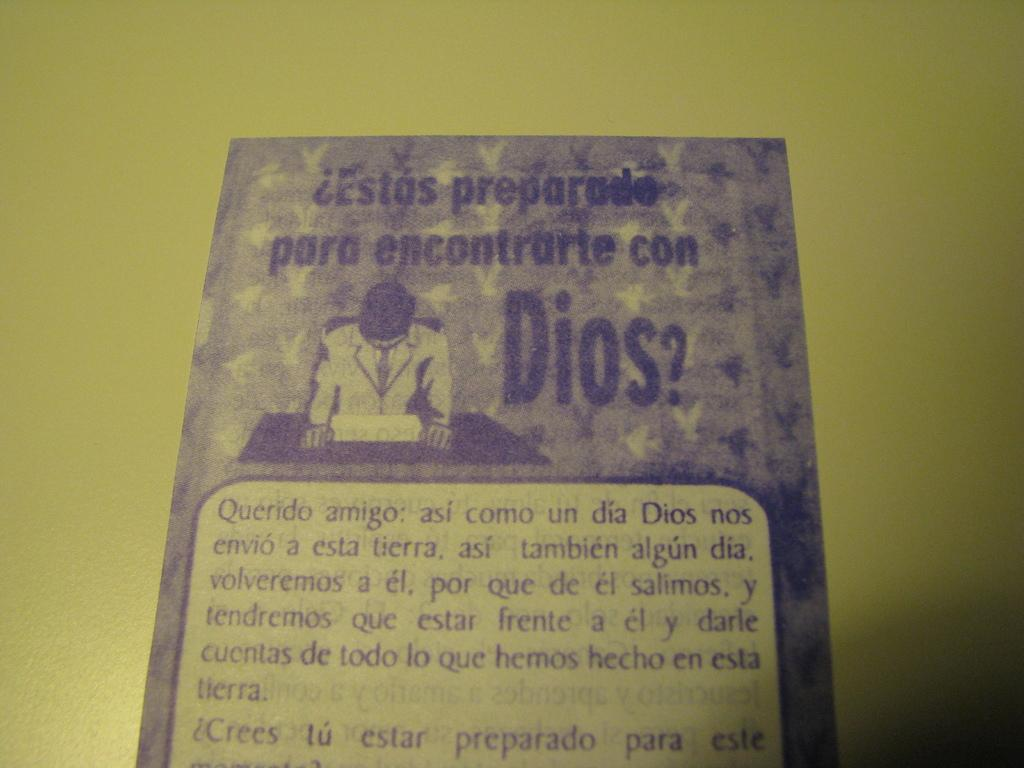<image>
Describe the image concisely. a pamphlet asking Estas preparade para encontrarte con Dios 